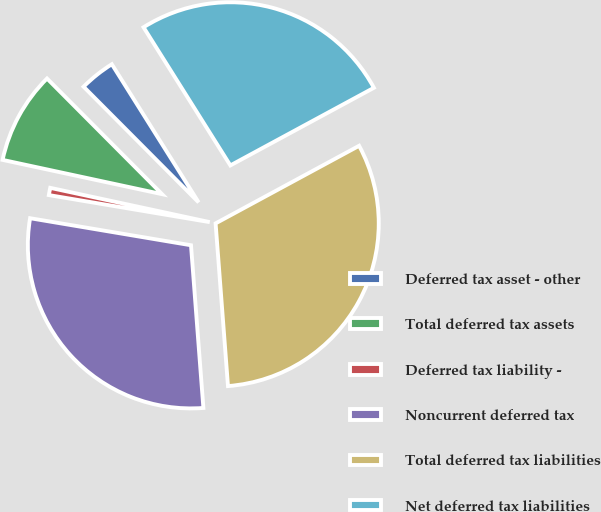<chart> <loc_0><loc_0><loc_500><loc_500><pie_chart><fcel>Deferred tax asset - other<fcel>Total deferred tax assets<fcel>Deferred tax liability -<fcel>Noncurrent deferred tax<fcel>Total deferred tax liabilities<fcel>Net deferred tax liabilities<nl><fcel>3.53%<fcel>9.17%<fcel>0.72%<fcel>28.86%<fcel>31.68%<fcel>26.04%<nl></chart> 